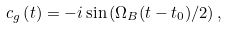<formula> <loc_0><loc_0><loc_500><loc_500>c _ { g } \left ( t \right ) = - i \sin \left ( \Omega _ { B } ( t - t _ { 0 } ) / 2 \right ) ,</formula> 